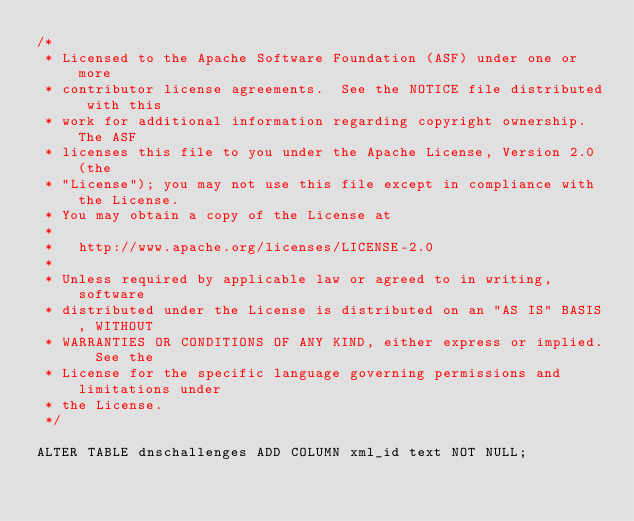<code> <loc_0><loc_0><loc_500><loc_500><_SQL_>/*
 * Licensed to the Apache Software Foundation (ASF) under one or more
 * contributor license agreements.  See the NOTICE file distributed with this
 * work for additional information regarding copyright ownership.  The ASF
 * licenses this file to you under the Apache License, Version 2.0 (the
 * "License"); you may not use this file except in compliance with the License.
 * You may obtain a copy of the License at
 *
 *   http://www.apache.org/licenses/LICENSE-2.0
 *
 * Unless required by applicable law or agreed to in writing, software
 * distributed under the License is distributed on an "AS IS" BASIS, WITHOUT
 * WARRANTIES OR CONDITIONS OF ANY KIND, either express or implied.  See the
 * License for the specific language governing permissions and limitations under
 * the License.
 */

ALTER TABLE dnschallenges ADD COLUMN xml_id text NOT NULL;
</code> 